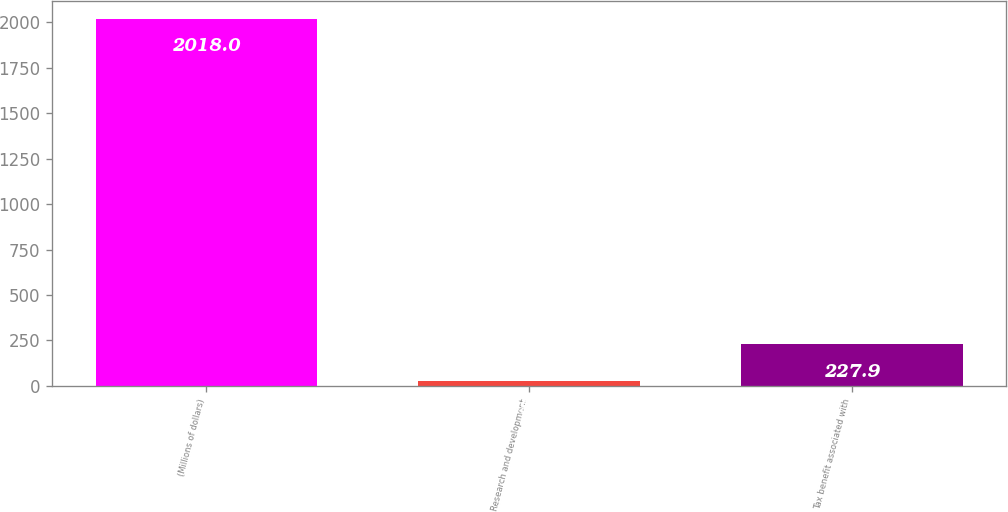Convert chart to OTSL. <chart><loc_0><loc_0><loc_500><loc_500><bar_chart><fcel>(Millions of dollars)<fcel>Research and development<fcel>Tax benefit associated with<nl><fcel>2018<fcel>29<fcel>227.9<nl></chart> 